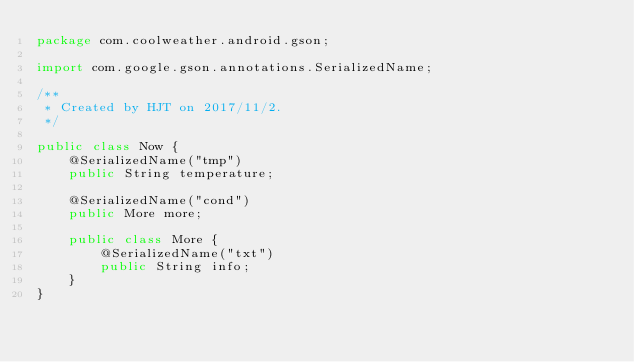Convert code to text. <code><loc_0><loc_0><loc_500><loc_500><_Java_>package com.coolweather.android.gson;

import com.google.gson.annotations.SerializedName;

/**
 * Created by HJT on 2017/11/2.
 */

public class Now {
    @SerializedName("tmp")
    public String temperature;

    @SerializedName("cond")
    public More more;

    public class More {
        @SerializedName("txt")
        public String info;
    }
}
</code> 